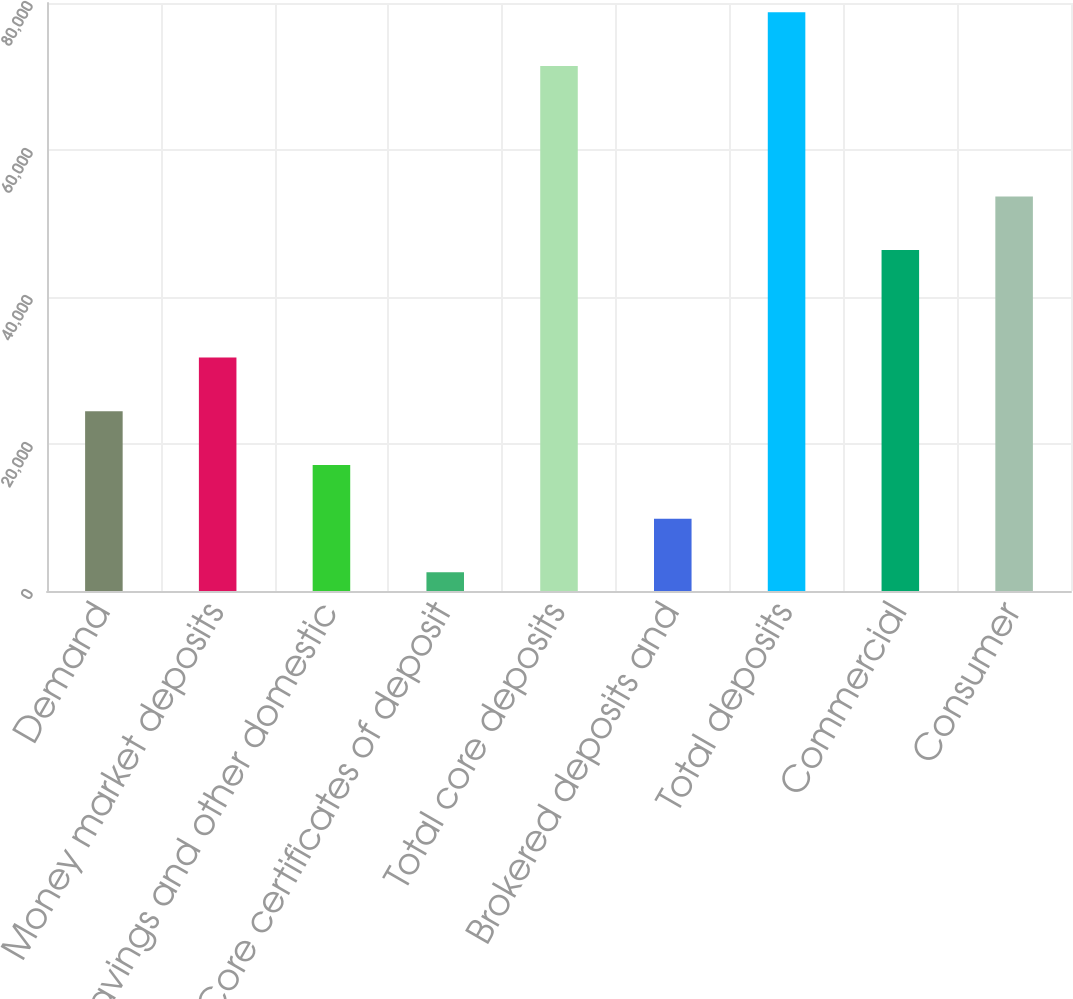<chart> <loc_0><loc_0><loc_500><loc_500><bar_chart><fcel>Demand<fcel>Money market deposits<fcel>Savings and other domestic<fcel>Core certificates of deposit<fcel>Total core deposits<fcel>Brokered deposits and<fcel>Total deposits<fcel>Commercial<fcel>Consumer<nl><fcel>24456.9<fcel>31764.2<fcel>17149.6<fcel>2535<fcel>71429<fcel>9842.3<fcel>78736.3<fcel>46378.8<fcel>53686.1<nl></chart> 